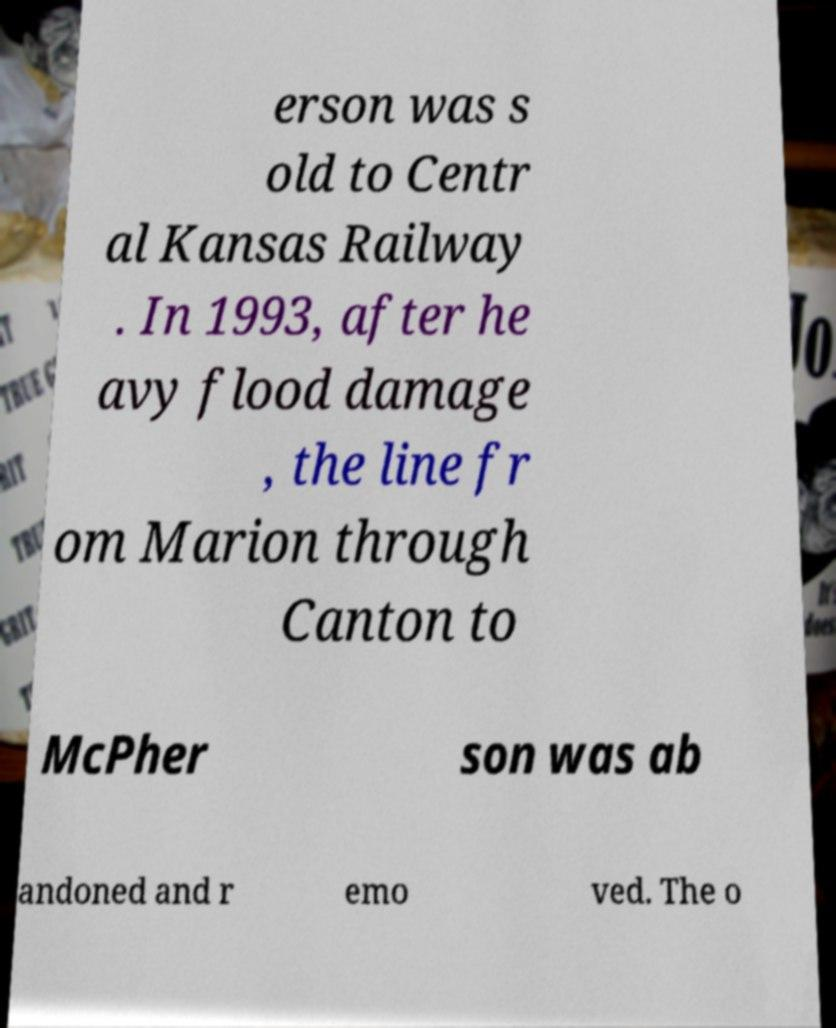Please identify and transcribe the text found in this image. erson was s old to Centr al Kansas Railway . In 1993, after he avy flood damage , the line fr om Marion through Canton to McPher son was ab andoned and r emo ved. The o 